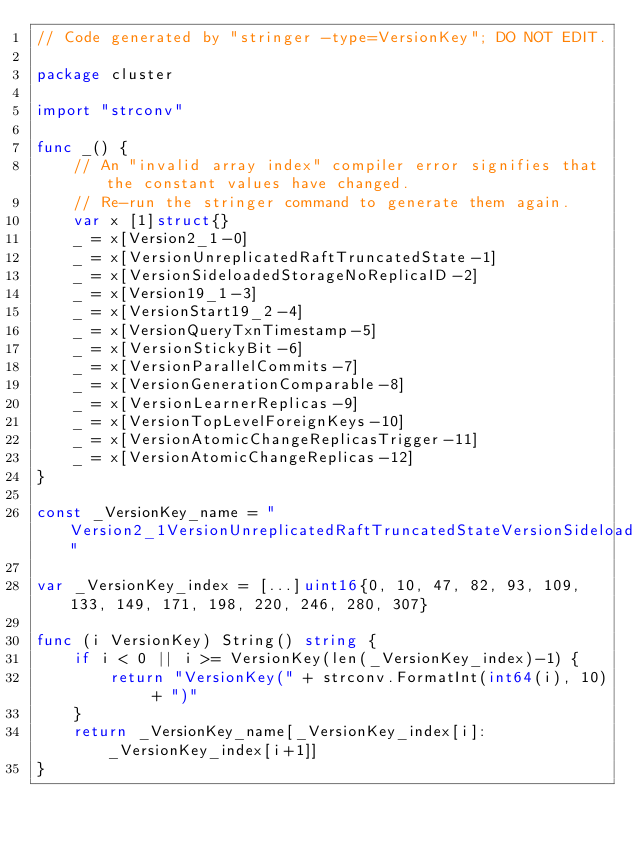Convert code to text. <code><loc_0><loc_0><loc_500><loc_500><_Go_>// Code generated by "stringer -type=VersionKey"; DO NOT EDIT.

package cluster

import "strconv"

func _() {
	// An "invalid array index" compiler error signifies that the constant values have changed.
	// Re-run the stringer command to generate them again.
	var x [1]struct{}
	_ = x[Version2_1-0]
	_ = x[VersionUnreplicatedRaftTruncatedState-1]
	_ = x[VersionSideloadedStorageNoReplicaID-2]
	_ = x[Version19_1-3]
	_ = x[VersionStart19_2-4]
	_ = x[VersionQueryTxnTimestamp-5]
	_ = x[VersionStickyBit-6]
	_ = x[VersionParallelCommits-7]
	_ = x[VersionGenerationComparable-8]
	_ = x[VersionLearnerReplicas-9]
	_ = x[VersionTopLevelForeignKeys-10]
	_ = x[VersionAtomicChangeReplicasTrigger-11]
	_ = x[VersionAtomicChangeReplicas-12]
}

const _VersionKey_name = "Version2_1VersionUnreplicatedRaftTruncatedStateVersionSideloadedStorageNoReplicaIDVersion19_1VersionStart19_2VersionQueryTxnTimestampVersionStickyBitVersionParallelCommitsVersionGenerationComparableVersionLearnerReplicasVersionTopLevelForeignKeysVersionAtomicChangeReplicasTriggerVersionAtomicChangeReplicas"

var _VersionKey_index = [...]uint16{0, 10, 47, 82, 93, 109, 133, 149, 171, 198, 220, 246, 280, 307}

func (i VersionKey) String() string {
	if i < 0 || i >= VersionKey(len(_VersionKey_index)-1) {
		return "VersionKey(" + strconv.FormatInt(int64(i), 10) + ")"
	}
	return _VersionKey_name[_VersionKey_index[i]:_VersionKey_index[i+1]]
}
</code> 